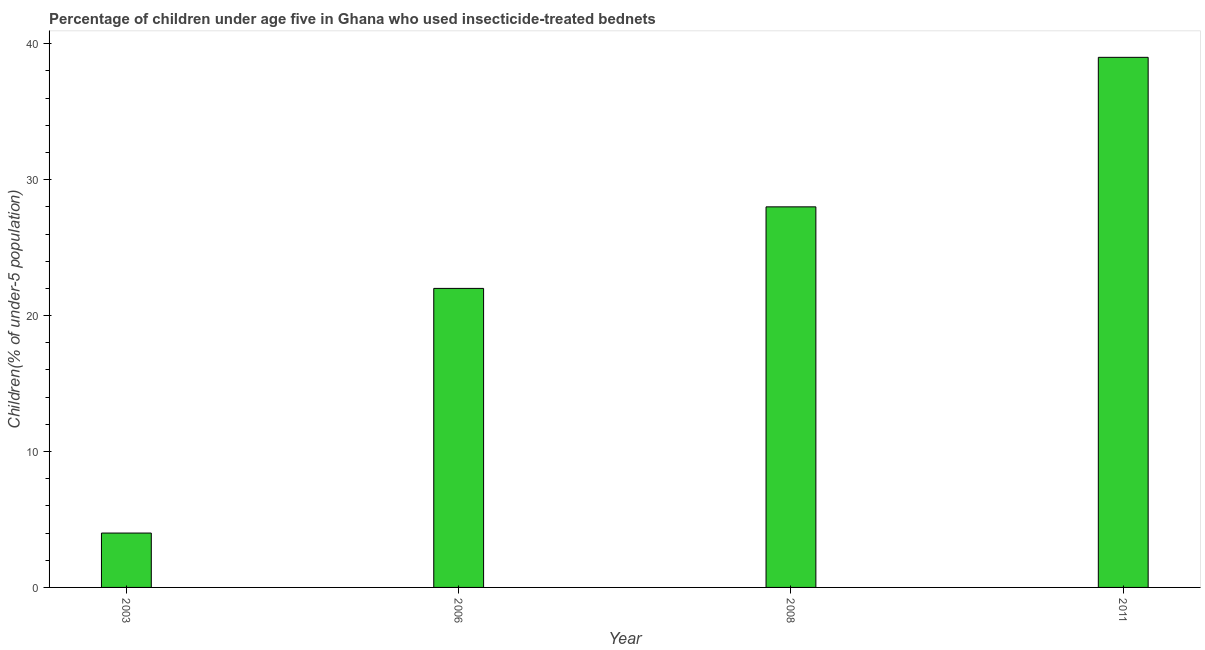Does the graph contain any zero values?
Your answer should be very brief. No. Does the graph contain grids?
Your response must be concise. No. What is the title of the graph?
Your answer should be very brief. Percentage of children under age five in Ghana who used insecticide-treated bednets. What is the label or title of the Y-axis?
Your response must be concise. Children(% of under-5 population). What is the sum of the percentage of children who use of insecticide-treated bed nets?
Keep it short and to the point. 93. What is the difference between the percentage of children who use of insecticide-treated bed nets in 2003 and 2008?
Give a very brief answer. -24. What is the median percentage of children who use of insecticide-treated bed nets?
Your response must be concise. 25. In how many years, is the percentage of children who use of insecticide-treated bed nets greater than 30 %?
Offer a very short reply. 1. Do a majority of the years between 2003 and 2008 (inclusive) have percentage of children who use of insecticide-treated bed nets greater than 34 %?
Your answer should be very brief. No. What is the ratio of the percentage of children who use of insecticide-treated bed nets in 2003 to that in 2011?
Ensure brevity in your answer.  0.1. Is the percentage of children who use of insecticide-treated bed nets in 2003 less than that in 2008?
Provide a succinct answer. Yes. Is the sum of the percentage of children who use of insecticide-treated bed nets in 2003 and 2006 greater than the maximum percentage of children who use of insecticide-treated bed nets across all years?
Provide a succinct answer. No. What is the difference between the highest and the lowest percentage of children who use of insecticide-treated bed nets?
Make the answer very short. 35. In how many years, is the percentage of children who use of insecticide-treated bed nets greater than the average percentage of children who use of insecticide-treated bed nets taken over all years?
Your answer should be very brief. 2. Are all the bars in the graph horizontal?
Give a very brief answer. No. How many years are there in the graph?
Offer a terse response. 4. What is the Children(% of under-5 population) in 2006?
Keep it short and to the point. 22. What is the Children(% of under-5 population) of 2011?
Make the answer very short. 39. What is the difference between the Children(% of under-5 population) in 2003 and 2011?
Provide a short and direct response. -35. What is the difference between the Children(% of under-5 population) in 2006 and 2008?
Ensure brevity in your answer.  -6. What is the ratio of the Children(% of under-5 population) in 2003 to that in 2006?
Offer a terse response. 0.18. What is the ratio of the Children(% of under-5 population) in 2003 to that in 2008?
Keep it short and to the point. 0.14. What is the ratio of the Children(% of under-5 population) in 2003 to that in 2011?
Your response must be concise. 0.1. What is the ratio of the Children(% of under-5 population) in 2006 to that in 2008?
Make the answer very short. 0.79. What is the ratio of the Children(% of under-5 population) in 2006 to that in 2011?
Provide a short and direct response. 0.56. What is the ratio of the Children(% of under-5 population) in 2008 to that in 2011?
Make the answer very short. 0.72. 